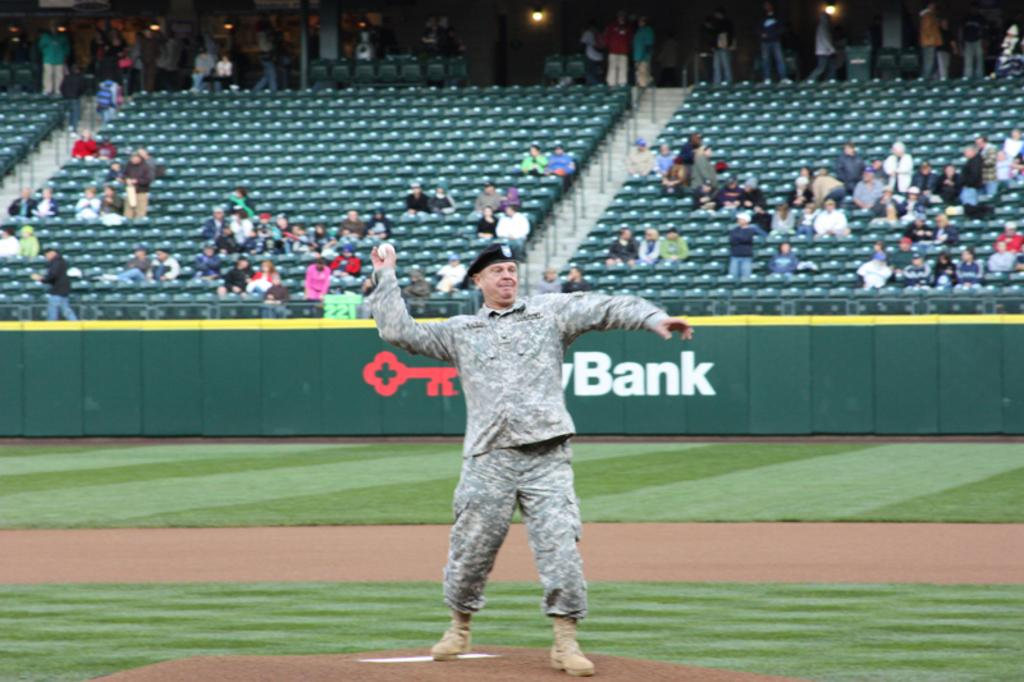<image>
Create a compact narrative representing the image presented. a man throwing a ball with the word Bank far behind 